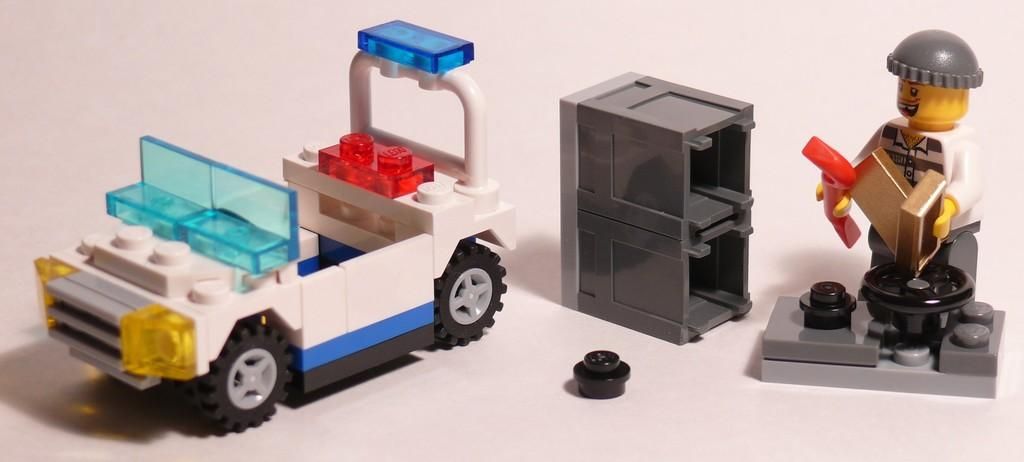What type of toy is present in the image? There are toys of a vehicle in the image. What piece of furniture can be seen in the image? There is a table in the image. Who is present in the image? There is a man in the image. What type of boat is visible in the image? There is no boat present in the image. Is the man holding a rifle in the image? There is no rifle present in the image. 